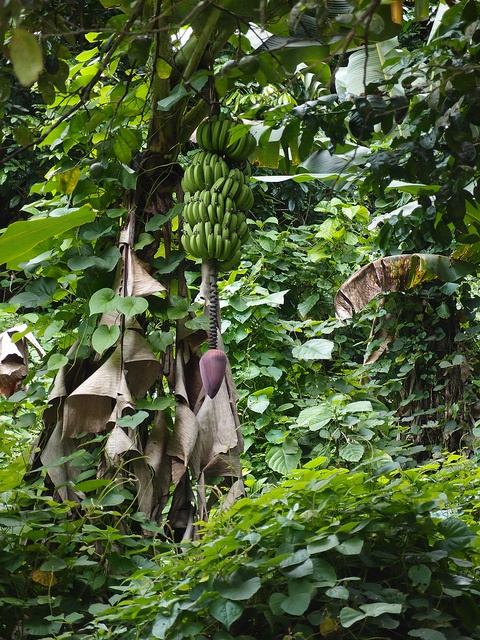Describe the objects in this image and their specific colors. I can see banana in black, darkgreen, and olive tones and banana in black, darkgreen, and olive tones in this image. 